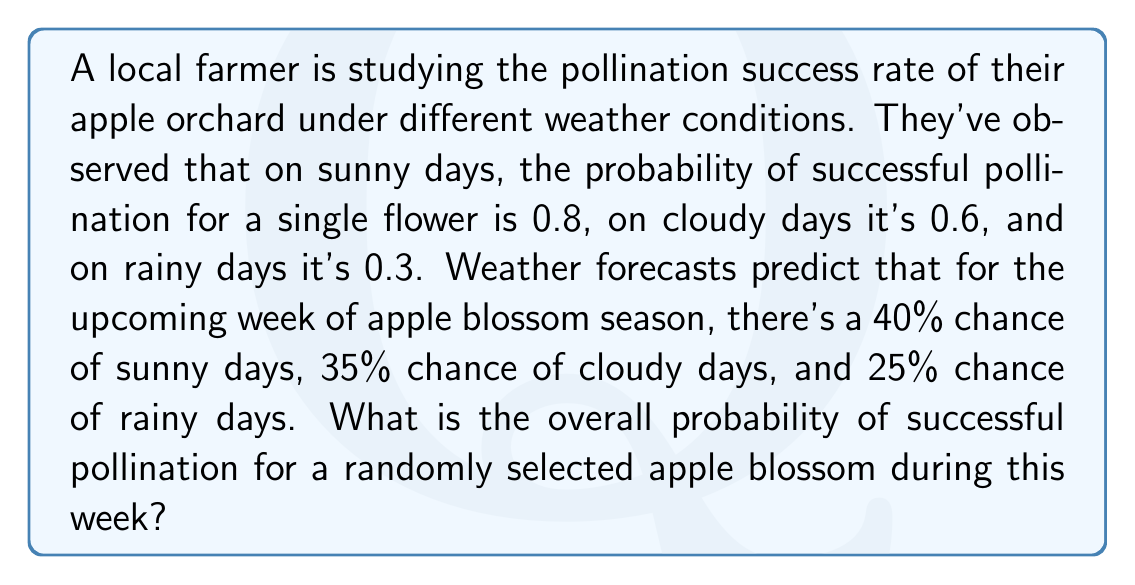Could you help me with this problem? To solve this problem, we'll use the law of total probability. Let's break it down step by step:

1) Define events:
   S: Sunny day
   C: Cloudy day
   R: Rainy day
   P: Successful pollination

2) Given probabilities:
   P(S) = 0.40
   P(C) = 0.35
   P(R) = 0.25
   P(P|S) = 0.8 (probability of pollination given a sunny day)
   P(P|C) = 0.6 (probability of pollination given a cloudy day)
   P(P|R) = 0.3 (probability of pollination given a rainy day)

3) The law of total probability states:
   $$P(P) = P(P|S) \cdot P(S) + P(P|C) \cdot P(C) + P(P|R) \cdot P(R)$$

4) Substituting the values:
   $$P(P) = 0.8 \cdot 0.40 + 0.6 \cdot 0.35 + 0.3 \cdot 0.25$$

5) Calculate:
   $$P(P) = 0.32 + 0.21 + 0.075 = 0.605$$

Therefore, the overall probability of successful pollination for a randomly selected apple blossom during this week is 0.605 or 60.5%.
Answer: $0.605$ or $60.5\%$ 